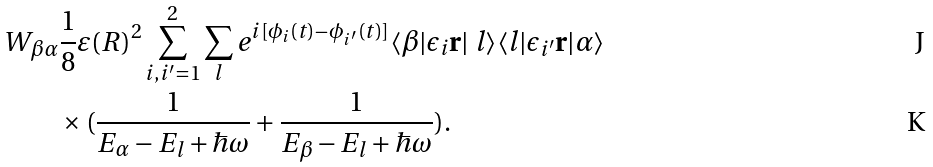Convert formula to latex. <formula><loc_0><loc_0><loc_500><loc_500>W _ { \beta \alpha } & \frac { 1 } { 8 } \varepsilon ( R ) ^ { 2 } \sum _ { i , i ^ { \prime } = 1 } ^ { 2 } \sum _ { l } e ^ { i [ \phi _ { i } ( t ) - \phi _ { i ^ { \prime } } ( t ) ] } \langle \beta | \epsilon _ { i } \mathbf r | \ l \rangle \langle l | \epsilon _ { i ^ { \prime } } \mathbf r | \alpha \rangle \\ & \times ( \frac { 1 } { E _ { \alpha } - E _ { l } + \hbar { \omega } } + \frac { 1 } { E _ { \beta } - E _ { l } + \hbar { \omega } } ) .</formula> 